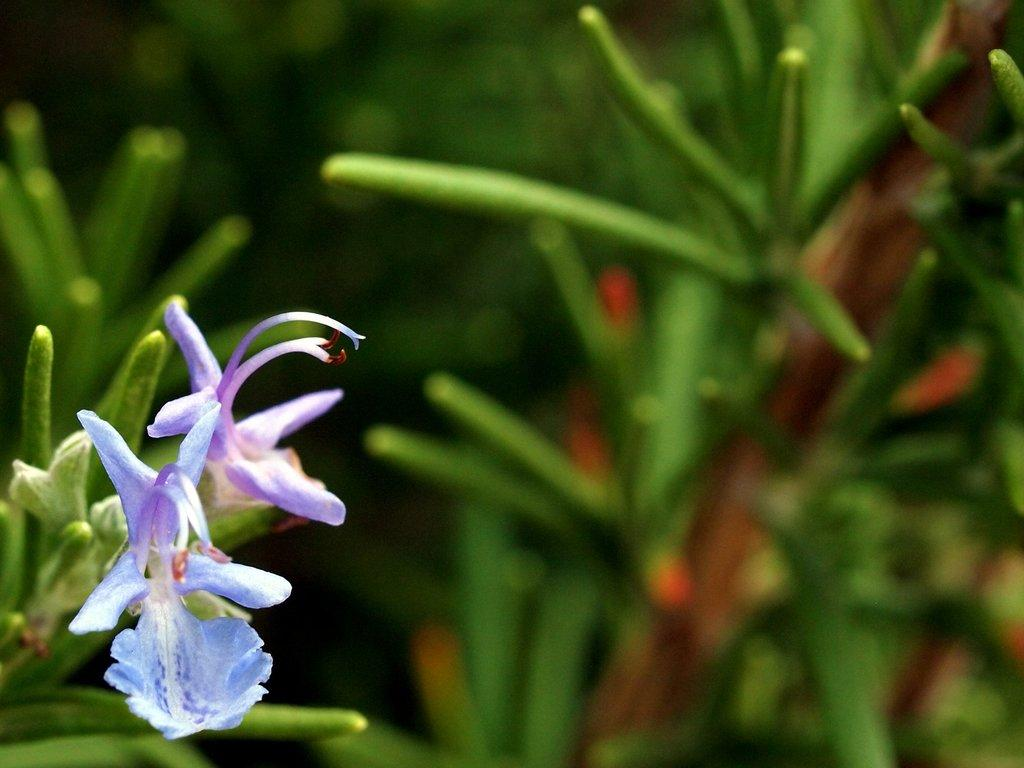What type of living organisms can be seen in the image? There are flowers on a plant in the image. Can you describe the surrounding environment in the image? There are other plants visible in the background of the image. How would you describe the appearance of the background in the image? The background of the image is blurred. What type of record can be seen playing in the background of the image? There is no record or any indication of music playing in the image; it features flowers on a plant and other plants in the background. 